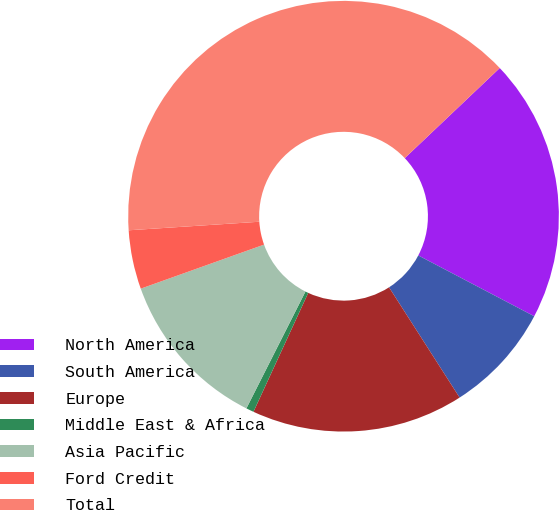Convert chart. <chart><loc_0><loc_0><loc_500><loc_500><pie_chart><fcel>North America<fcel>South America<fcel>Europe<fcel>Middle East & Africa<fcel>Asia Pacific<fcel>Ford Credit<fcel>Total<nl><fcel>19.77%<fcel>8.25%<fcel>15.93%<fcel>0.58%<fcel>12.09%<fcel>4.42%<fcel>38.96%<nl></chart> 